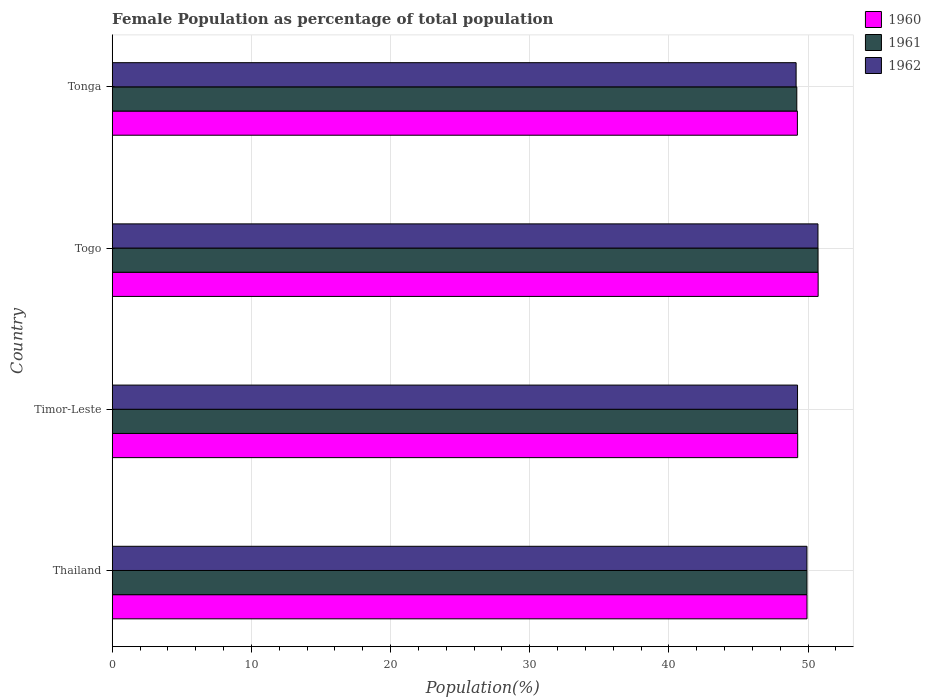How many different coloured bars are there?
Keep it short and to the point. 3. Are the number of bars on each tick of the Y-axis equal?
Your answer should be very brief. Yes. How many bars are there on the 4th tick from the top?
Give a very brief answer. 3. How many bars are there on the 4th tick from the bottom?
Provide a short and direct response. 3. What is the label of the 4th group of bars from the top?
Your answer should be very brief. Thailand. In how many cases, is the number of bars for a given country not equal to the number of legend labels?
Keep it short and to the point. 0. What is the female population in in 1960 in Thailand?
Offer a terse response. 49.93. Across all countries, what is the maximum female population in in 1961?
Offer a terse response. 50.72. Across all countries, what is the minimum female population in in 1960?
Your answer should be compact. 49.24. In which country was the female population in in 1960 maximum?
Provide a succinct answer. Togo. In which country was the female population in in 1961 minimum?
Your response must be concise. Tonga. What is the total female population in in 1961 in the graph?
Offer a terse response. 199.09. What is the difference between the female population in in 1962 in Timor-Leste and that in Togo?
Your answer should be very brief. -1.47. What is the difference between the female population in in 1961 in Thailand and the female population in in 1960 in Timor-Leste?
Keep it short and to the point. 0.67. What is the average female population in in 1962 per country?
Offer a very short reply. 49.76. What is the difference between the female population in in 1961 and female population in in 1960 in Tonga?
Your answer should be compact. -0.04. In how many countries, is the female population in in 1962 greater than 32 %?
Offer a very short reply. 4. What is the ratio of the female population in in 1960 in Thailand to that in Timor-Leste?
Provide a short and direct response. 1.01. Is the female population in in 1962 in Thailand less than that in Timor-Leste?
Make the answer very short. No. What is the difference between the highest and the second highest female population in in 1960?
Provide a succinct answer. 0.8. What is the difference between the highest and the lowest female population in in 1962?
Give a very brief answer. 1.57. In how many countries, is the female population in in 1961 greater than the average female population in in 1961 taken over all countries?
Ensure brevity in your answer.  2. Is the sum of the female population in in 1962 in Togo and Tonga greater than the maximum female population in in 1961 across all countries?
Make the answer very short. Yes. Is it the case that in every country, the sum of the female population in in 1960 and female population in in 1962 is greater than the female population in in 1961?
Make the answer very short. Yes. How many countries are there in the graph?
Your answer should be very brief. 4. What is the difference between two consecutive major ticks on the X-axis?
Ensure brevity in your answer.  10. How are the legend labels stacked?
Ensure brevity in your answer.  Vertical. What is the title of the graph?
Your answer should be compact. Female Population as percentage of total population. What is the label or title of the X-axis?
Your answer should be compact. Population(%). What is the Population(%) of 1960 in Thailand?
Your response must be concise. 49.93. What is the Population(%) in 1961 in Thailand?
Offer a terse response. 49.92. What is the Population(%) of 1962 in Thailand?
Make the answer very short. 49.92. What is the Population(%) of 1960 in Timor-Leste?
Provide a short and direct response. 49.26. What is the Population(%) in 1961 in Timor-Leste?
Offer a very short reply. 49.25. What is the Population(%) in 1962 in Timor-Leste?
Give a very brief answer. 49.25. What is the Population(%) of 1960 in Togo?
Offer a terse response. 50.73. What is the Population(%) in 1961 in Togo?
Ensure brevity in your answer.  50.72. What is the Population(%) in 1962 in Togo?
Offer a very short reply. 50.71. What is the Population(%) in 1960 in Tonga?
Provide a short and direct response. 49.24. What is the Population(%) of 1961 in Tonga?
Your answer should be compact. 49.19. What is the Population(%) in 1962 in Tonga?
Offer a terse response. 49.14. Across all countries, what is the maximum Population(%) in 1960?
Give a very brief answer. 50.73. Across all countries, what is the maximum Population(%) in 1961?
Your answer should be very brief. 50.72. Across all countries, what is the maximum Population(%) in 1962?
Keep it short and to the point. 50.71. Across all countries, what is the minimum Population(%) of 1960?
Provide a short and direct response. 49.24. Across all countries, what is the minimum Population(%) in 1961?
Provide a short and direct response. 49.19. Across all countries, what is the minimum Population(%) of 1962?
Keep it short and to the point. 49.14. What is the total Population(%) of 1960 in the graph?
Ensure brevity in your answer.  199.14. What is the total Population(%) in 1961 in the graph?
Make the answer very short. 199.09. What is the total Population(%) in 1962 in the graph?
Ensure brevity in your answer.  199.02. What is the difference between the Population(%) of 1960 in Thailand and that in Timor-Leste?
Offer a very short reply. 0.67. What is the difference between the Population(%) of 1961 in Thailand and that in Timor-Leste?
Provide a short and direct response. 0.67. What is the difference between the Population(%) of 1962 in Thailand and that in Timor-Leste?
Keep it short and to the point. 0.68. What is the difference between the Population(%) of 1960 in Thailand and that in Togo?
Provide a short and direct response. -0.8. What is the difference between the Population(%) in 1961 in Thailand and that in Togo?
Keep it short and to the point. -0.8. What is the difference between the Population(%) of 1962 in Thailand and that in Togo?
Provide a short and direct response. -0.79. What is the difference between the Population(%) in 1960 in Thailand and that in Tonga?
Keep it short and to the point. 0.69. What is the difference between the Population(%) of 1961 in Thailand and that in Tonga?
Offer a very short reply. 0.73. What is the difference between the Population(%) of 1962 in Thailand and that in Tonga?
Ensure brevity in your answer.  0.78. What is the difference between the Population(%) of 1960 in Timor-Leste and that in Togo?
Provide a short and direct response. -1.47. What is the difference between the Population(%) in 1961 in Timor-Leste and that in Togo?
Make the answer very short. -1.47. What is the difference between the Population(%) in 1962 in Timor-Leste and that in Togo?
Offer a terse response. -1.47. What is the difference between the Population(%) in 1960 in Timor-Leste and that in Tonga?
Keep it short and to the point. 0.02. What is the difference between the Population(%) of 1961 in Timor-Leste and that in Tonga?
Keep it short and to the point. 0.06. What is the difference between the Population(%) of 1962 in Timor-Leste and that in Tonga?
Ensure brevity in your answer.  0.1. What is the difference between the Population(%) in 1960 in Togo and that in Tonga?
Provide a succinct answer. 1.49. What is the difference between the Population(%) in 1961 in Togo and that in Tonga?
Keep it short and to the point. 1.53. What is the difference between the Population(%) in 1962 in Togo and that in Tonga?
Offer a very short reply. 1.57. What is the difference between the Population(%) in 1960 in Thailand and the Population(%) in 1961 in Timor-Leste?
Keep it short and to the point. 0.67. What is the difference between the Population(%) of 1960 in Thailand and the Population(%) of 1962 in Timor-Leste?
Your answer should be compact. 0.68. What is the difference between the Population(%) in 1961 in Thailand and the Population(%) in 1962 in Timor-Leste?
Keep it short and to the point. 0.68. What is the difference between the Population(%) of 1960 in Thailand and the Population(%) of 1961 in Togo?
Provide a short and direct response. -0.79. What is the difference between the Population(%) in 1960 in Thailand and the Population(%) in 1962 in Togo?
Provide a succinct answer. -0.79. What is the difference between the Population(%) of 1961 in Thailand and the Population(%) of 1962 in Togo?
Your response must be concise. -0.79. What is the difference between the Population(%) of 1960 in Thailand and the Population(%) of 1961 in Tonga?
Make the answer very short. 0.73. What is the difference between the Population(%) of 1960 in Thailand and the Population(%) of 1962 in Tonga?
Provide a short and direct response. 0.78. What is the difference between the Population(%) in 1961 in Thailand and the Population(%) in 1962 in Tonga?
Provide a short and direct response. 0.78. What is the difference between the Population(%) in 1960 in Timor-Leste and the Population(%) in 1961 in Togo?
Your answer should be compact. -1.46. What is the difference between the Population(%) of 1960 in Timor-Leste and the Population(%) of 1962 in Togo?
Your response must be concise. -1.46. What is the difference between the Population(%) in 1961 in Timor-Leste and the Population(%) in 1962 in Togo?
Provide a short and direct response. -1.46. What is the difference between the Population(%) of 1960 in Timor-Leste and the Population(%) of 1961 in Tonga?
Offer a very short reply. 0.06. What is the difference between the Population(%) of 1960 in Timor-Leste and the Population(%) of 1962 in Tonga?
Provide a short and direct response. 0.11. What is the difference between the Population(%) of 1961 in Timor-Leste and the Population(%) of 1962 in Tonga?
Ensure brevity in your answer.  0.11. What is the difference between the Population(%) in 1960 in Togo and the Population(%) in 1961 in Tonga?
Provide a short and direct response. 1.53. What is the difference between the Population(%) in 1960 in Togo and the Population(%) in 1962 in Tonga?
Offer a terse response. 1.58. What is the difference between the Population(%) of 1961 in Togo and the Population(%) of 1962 in Tonga?
Offer a terse response. 1.58. What is the average Population(%) of 1960 per country?
Provide a succinct answer. 49.79. What is the average Population(%) in 1961 per country?
Your answer should be very brief. 49.77. What is the average Population(%) in 1962 per country?
Offer a very short reply. 49.76. What is the difference between the Population(%) of 1960 and Population(%) of 1961 in Thailand?
Give a very brief answer. 0. What is the difference between the Population(%) of 1960 and Population(%) of 1962 in Thailand?
Provide a succinct answer. 0. What is the difference between the Population(%) of 1961 and Population(%) of 1962 in Thailand?
Keep it short and to the point. 0. What is the difference between the Population(%) in 1960 and Population(%) in 1961 in Timor-Leste?
Offer a terse response. 0.01. What is the difference between the Population(%) in 1960 and Population(%) in 1962 in Timor-Leste?
Keep it short and to the point. 0.01. What is the difference between the Population(%) in 1961 and Population(%) in 1962 in Timor-Leste?
Your answer should be very brief. 0.01. What is the difference between the Population(%) in 1960 and Population(%) in 1961 in Togo?
Your response must be concise. 0.01. What is the difference between the Population(%) of 1960 and Population(%) of 1962 in Togo?
Ensure brevity in your answer.  0.01. What is the difference between the Population(%) of 1961 and Population(%) of 1962 in Togo?
Provide a succinct answer. 0.01. What is the difference between the Population(%) of 1960 and Population(%) of 1961 in Tonga?
Offer a very short reply. 0.04. What is the difference between the Population(%) of 1960 and Population(%) of 1962 in Tonga?
Keep it short and to the point. 0.09. What is the difference between the Population(%) in 1961 and Population(%) in 1962 in Tonga?
Make the answer very short. 0.05. What is the ratio of the Population(%) in 1960 in Thailand to that in Timor-Leste?
Provide a succinct answer. 1.01. What is the ratio of the Population(%) in 1961 in Thailand to that in Timor-Leste?
Make the answer very short. 1.01. What is the ratio of the Population(%) of 1962 in Thailand to that in Timor-Leste?
Provide a succinct answer. 1.01. What is the ratio of the Population(%) of 1960 in Thailand to that in Togo?
Offer a very short reply. 0.98. What is the ratio of the Population(%) in 1961 in Thailand to that in Togo?
Your answer should be very brief. 0.98. What is the ratio of the Population(%) in 1962 in Thailand to that in Togo?
Ensure brevity in your answer.  0.98. What is the ratio of the Population(%) in 1960 in Thailand to that in Tonga?
Make the answer very short. 1.01. What is the ratio of the Population(%) in 1961 in Thailand to that in Tonga?
Provide a short and direct response. 1.01. What is the ratio of the Population(%) in 1962 in Thailand to that in Tonga?
Make the answer very short. 1.02. What is the ratio of the Population(%) in 1960 in Timor-Leste to that in Togo?
Offer a terse response. 0.97. What is the ratio of the Population(%) of 1962 in Timor-Leste to that in Togo?
Make the answer very short. 0.97. What is the ratio of the Population(%) of 1961 in Timor-Leste to that in Tonga?
Provide a succinct answer. 1. What is the ratio of the Population(%) of 1962 in Timor-Leste to that in Tonga?
Offer a very short reply. 1. What is the ratio of the Population(%) of 1960 in Togo to that in Tonga?
Your response must be concise. 1.03. What is the ratio of the Population(%) in 1961 in Togo to that in Tonga?
Offer a terse response. 1.03. What is the ratio of the Population(%) in 1962 in Togo to that in Tonga?
Give a very brief answer. 1.03. What is the difference between the highest and the second highest Population(%) in 1960?
Make the answer very short. 0.8. What is the difference between the highest and the second highest Population(%) in 1961?
Your response must be concise. 0.8. What is the difference between the highest and the second highest Population(%) in 1962?
Your answer should be very brief. 0.79. What is the difference between the highest and the lowest Population(%) of 1960?
Offer a very short reply. 1.49. What is the difference between the highest and the lowest Population(%) in 1961?
Your answer should be very brief. 1.53. What is the difference between the highest and the lowest Population(%) of 1962?
Your response must be concise. 1.57. 